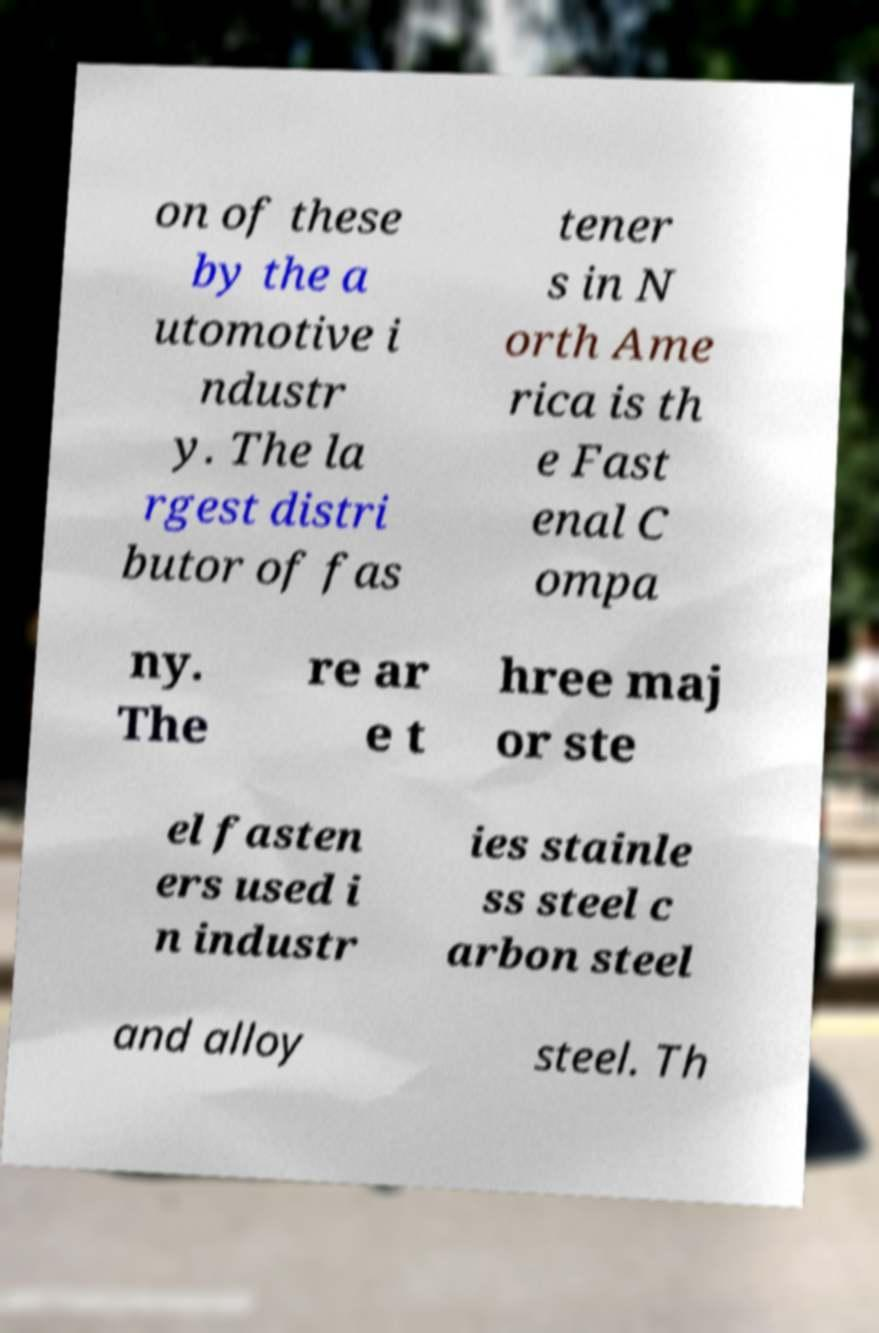Please read and relay the text visible in this image. What does it say? on of these by the a utomotive i ndustr y. The la rgest distri butor of fas tener s in N orth Ame rica is th e Fast enal C ompa ny. The re ar e t hree maj or ste el fasten ers used i n industr ies stainle ss steel c arbon steel and alloy steel. Th 